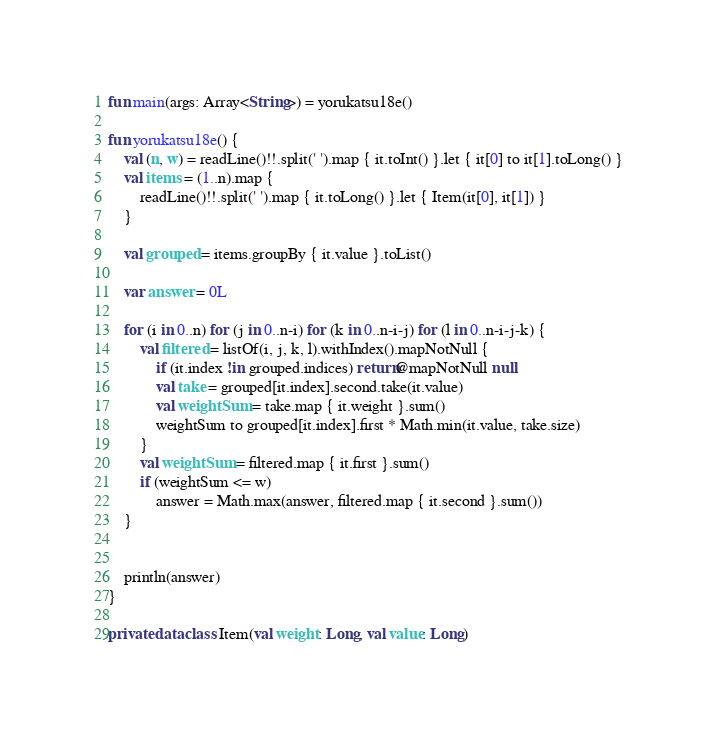Convert code to text. <code><loc_0><loc_0><loc_500><loc_500><_Kotlin_>fun main(args: Array<String>) = yorukatsu18e()

fun yorukatsu18e() {
    val (n, w) = readLine()!!.split(' ').map { it.toInt() }.let { it[0] to it[1].toLong() }
    val items = (1..n).map {
        readLine()!!.split(' ').map { it.toLong() }.let { Item(it[0], it[1]) }
    }

    val grouped = items.groupBy { it.value }.toList()

    var answer = 0L

    for (i in 0..n) for (j in 0..n-i) for (k in 0..n-i-j) for (l in 0..n-i-j-k) {
        val filtered = listOf(i, j, k, l).withIndex().mapNotNull {
            if (it.index !in grouped.indices) return@mapNotNull null
            val take = grouped[it.index].second.take(it.value)
            val weightSum = take.map { it.weight }.sum()
            weightSum to grouped[it.index].first * Math.min(it.value, take.size)
        }
        val weightSum = filtered.map { it.first }.sum()
        if (weightSum <= w)
            answer = Math.max(answer, filtered.map { it.second }.sum())
    }


    println(answer)
}

private data class Item(val weight: Long, val value: Long)
</code> 